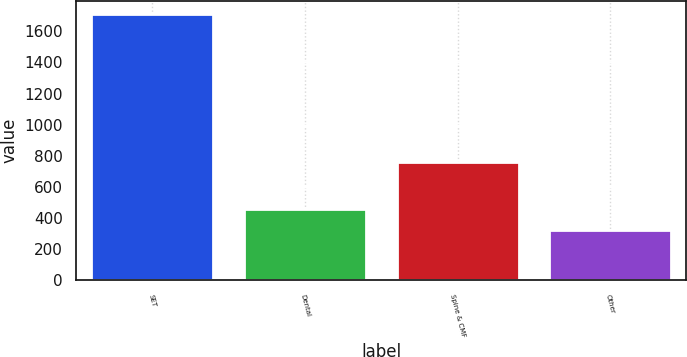<chart> <loc_0><loc_0><loc_500><loc_500><bar_chart><fcel>SET<fcel>Dental<fcel>Spine & CMF<fcel>Other<nl><fcel>1709.1<fcel>459.54<fcel>759.5<fcel>320.7<nl></chart> 